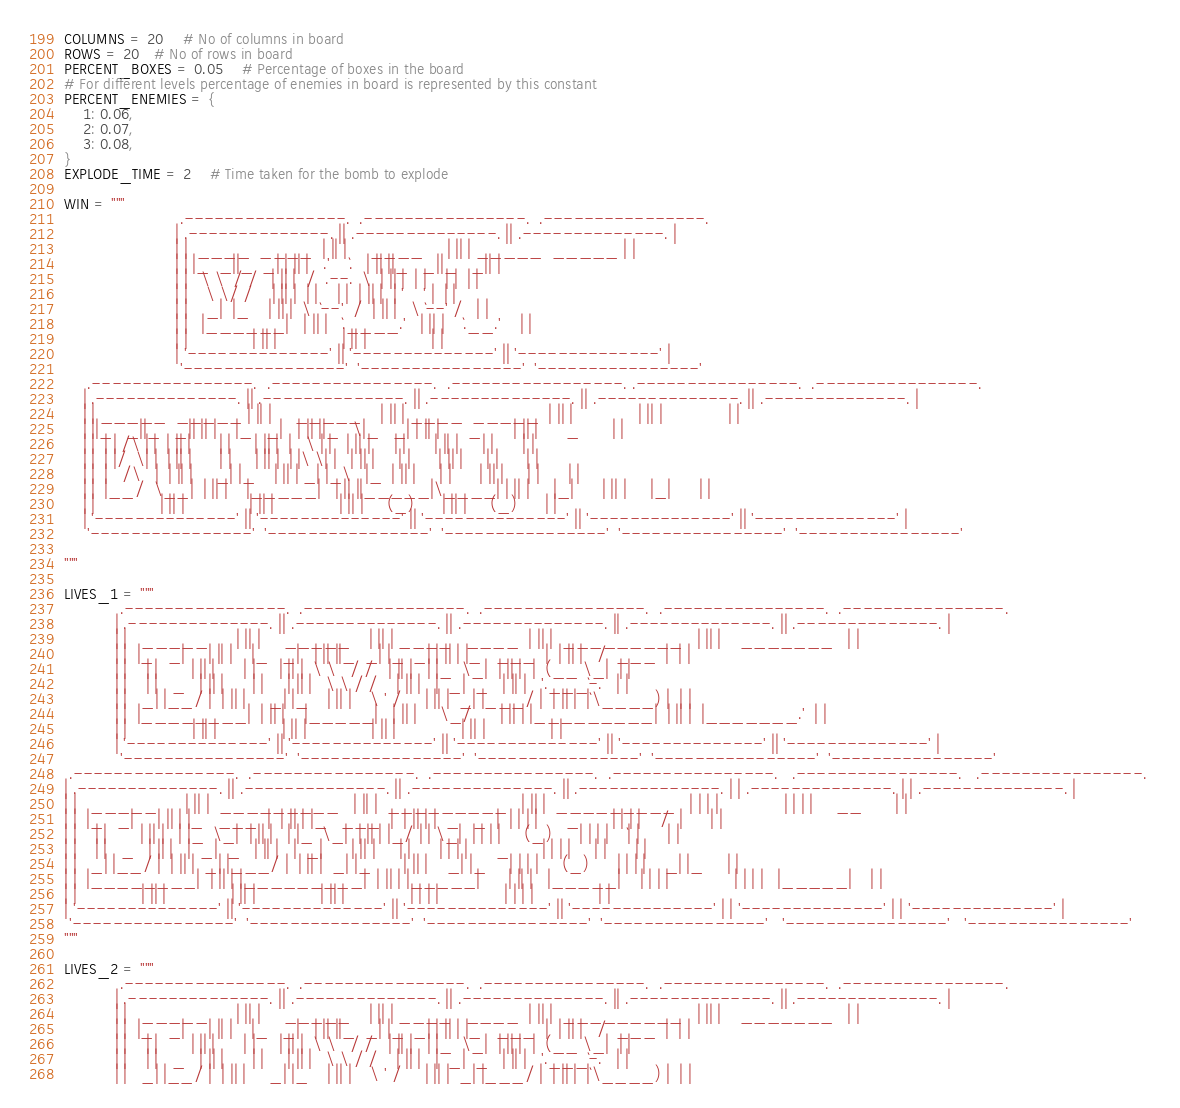<code> <loc_0><loc_0><loc_500><loc_500><_Python_>COLUMNS = 20    # No of columns in board
ROWS = 20   # No of rows in board
PERCENT_BOXES = 0.05    # Percentage of boxes in the board
# For different levels percentage of enemies in board is represented by this constant
PERCENT_ENEMIES = {
    1: 0.06,
    2: 0.07,
    3: 0.08,
}
EXPLODE_TIME = 2    # Time taken for the bomb to explode

WIN = """
	                     .----------------.  .----------------.  .----------------.                     
	                    | .--------------. || .--------------. || .--------------. |                    
	                    | |  ____  ____  | || |     ____     | || | _____  _____ | |                    
	                    | | |_  _||_  _| | || |   .'    `.   | || ||_   _||_   _|| |                    
	                    | |   \ \  / /   | || |  /  .--.  \  | || |  | |    | |  | |                    
	                    | |    \ \/ /    | || |  | |    | |  | || |  | '    ' |  | |                    
	                    | |    _|  |_    | || |  \  `--'  /  | || |   \ `--' /   | |                    
	                    | |   |______|   | || |   `.____.'   | || |    `.__.'    | |                    
	                    | |              | || |              | || |              | |                    
	                    | '--------------' || '--------------' || '--------------' |                    
	                     '----------------'  '----------------'  '----------------'                     
	 .----------------.  .----------------.  .-----------------. .----------------.  .----------------. 
	| .--------------. || .--------------. || .--------------. || .--------------. || .--------------. |
	| | _____  _____ | || |     _____    | || | ____  _____  | || |              | || |              | |
	| ||_   _||_   _|| || |    |_   _|   | || ||_   \|_   _| | || |      _       | || |      _       | |
	| |  | | /\ | |  | || |      | |     | || |  |   \ | |   | || |     | |      | || |     | |      | |
	| |  | |/  \| |  | || |      | |     | || |  | |\ \| |   | || |     | |      | || |     | |      | |
	| |  |   /\   |  | || |     _| |_    | || | _| |_\   |_  | || |     | |      | || |     | |      | |
	| |  |__/  \__|  | || |    |_____|   | || ||_____|\____| | || |     |_|      | || |     |_|      | |
	| |              | || |              | || |              | || |     (_)      | || |     (_)      | |
	| '--------------' || '--------------' || '--------------' || '--------------' || '--------------' |
	 '----------------'  '----------------'  '----------------'  '----------------'  '----------------' 

"""

LIVES_1 = """
            .----------------.  .----------------.  .----------------.  .----------------.  .----------------.            
           | .--------------. || .--------------. || .--------------. || .--------------. || .--------------. |           
           | |   _____      | || |     _____    | || | ____   ____  | || |  _________   | || |    _______   | |           
           | |  |_   _|     | || |    |_   _|   | || ||_  _| |_  _| | || | |_   ___  |  | || |   /  ___  |  | |           
           | |    | |       | || |      | |     | || |  \ \   / /   | || |   | |_  \_|  | || |  |  (__ \_|  | |           
           | |    | |   _   | || |      | |     | || |   \ \ / /    | || |   |  _|  _   | || |   '.___`-.   | |           
           | |   _| |__/ |  | || |     _| |_    | || |    \ ' /     | || |  _| |___/ |  | || |  |`\____) |  | |           
           | |  |________|  | || |    |_____|   | || |     \_/      | || | |_________|  | || |  |_______.'  | |           
           | |              | || |              | || |              | || |              | || |              | |           
           | '--------------' || '--------------' || '--------------' || '--------------' || '--------------' |           
            '----------------'  '----------------'  '----------------'  '----------------'  '----------------'            
 .----------------.  .----------------.  .----------------.  .----------------.   .----------------.   .----------------. 
| .--------------. || .--------------. || .--------------. || .--------------. | | .--------------. | | .--------------. |
| |   _____      | || |  _________   | || |  _________   | || |  _________   | | | |              | | | |     __       | |
| |  |_   _|     | || | |_   ___  |  | || | |_   ___  |  | || | |  _   _  |  | | | |      _       | | | |    /  |      | |
| |    | |       | || |   | |_  \_|  | || |   | |_  \_|  | || | |_/ | | \_|  | | | |     (_)      | | | |    `| |      | |
| |    | |   _   | || |   |  _|  _   | || |   |  _|      | || |     | |      | | | |      _       | | | |     | |      | |
| |   _| |__/ |  | || |  _| |___/ |  | || |  _| |_       | || |    _| |_     | | | |     (_)      | | | |    _| |_     | |
| |  |________|  | || | |_________|  | || | |_____|      | || |   |_____|    | | | |              | | | |   |_____|    | |
| |              | || |              | || |              | || |              | | | |              | | | |              | |
| '--------------' || '--------------' || '--------------' || '--------------' | | '--------------' | | '--------------' |
 '----------------'  '----------------'  '----------------'  '----------------'   '----------------'   '----------------' 
"""

LIVES_2 = """
            .----------------.  .----------------.  .----------------.  .----------------.  .----------------.            
           | .--------------. || .--------------. || .--------------. || .--------------. || .--------------. |           
           | |   _____      | || |     _____    | || | ____   ____  | || |  _________   | || |    _______   | |           
           | |  |_   _|     | || |    |_   _|   | || ||_  _| |_  _| | || | |_   ___  |  | || |   /  ___  |  | |           
           | |    | |       | || |      | |     | || |  \ \   / /   | || |   | |_  \_|  | || |  |  (__ \_|  | |           
           | |    | |   _   | || |      | |     | || |   \ \ / /    | || |   |  _|  _   | || |   '.___`-.   | |           
           | |   _| |__/ |  | || |     _| |_    | || |    \ ' /     | || |  _| |___/ |  | || |  |`\____) |  | |           </code> 